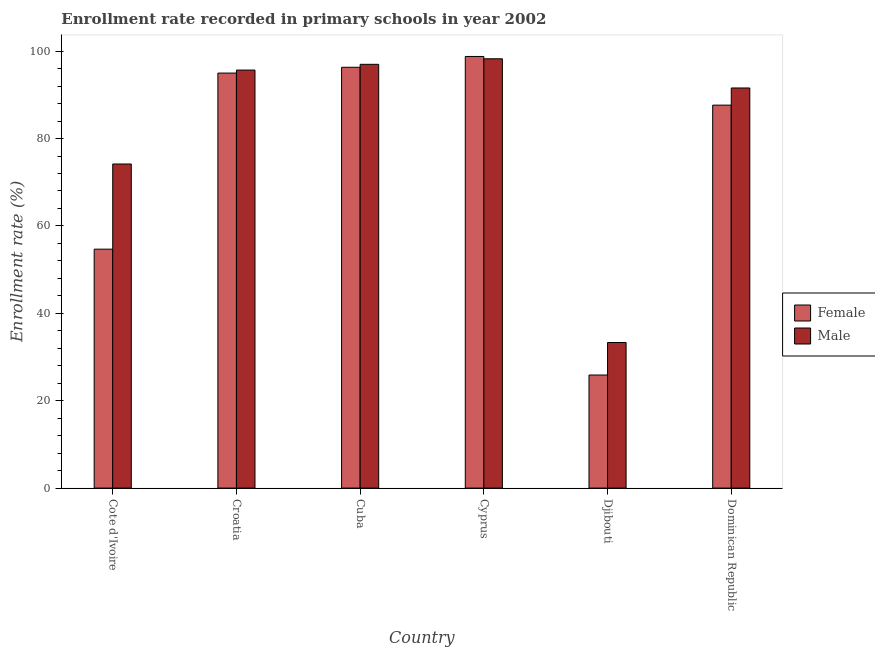How many different coloured bars are there?
Ensure brevity in your answer.  2. Are the number of bars on each tick of the X-axis equal?
Offer a terse response. Yes. How many bars are there on the 2nd tick from the right?
Your answer should be very brief. 2. What is the label of the 3rd group of bars from the left?
Your answer should be compact. Cuba. In how many cases, is the number of bars for a given country not equal to the number of legend labels?
Your answer should be compact. 0. What is the enrollment rate of female students in Cote d'Ivoire?
Give a very brief answer. 54.68. Across all countries, what is the maximum enrollment rate of male students?
Keep it short and to the point. 98.25. Across all countries, what is the minimum enrollment rate of male students?
Provide a succinct answer. 33.32. In which country was the enrollment rate of female students maximum?
Keep it short and to the point. Cyprus. In which country was the enrollment rate of male students minimum?
Give a very brief answer. Djibouti. What is the total enrollment rate of male students in the graph?
Give a very brief answer. 489.96. What is the difference between the enrollment rate of female students in Croatia and that in Dominican Republic?
Provide a short and direct response. 7.34. What is the difference between the enrollment rate of female students in Cote d'Ivoire and the enrollment rate of male students in Dominican Republic?
Ensure brevity in your answer.  -36.89. What is the average enrollment rate of female students per country?
Offer a terse response. 76.38. What is the difference between the enrollment rate of female students and enrollment rate of male students in Croatia?
Give a very brief answer. -0.69. What is the ratio of the enrollment rate of female students in Djibouti to that in Dominican Republic?
Your answer should be compact. 0.3. Is the enrollment rate of female students in Croatia less than that in Cuba?
Ensure brevity in your answer.  Yes. Is the difference between the enrollment rate of male students in Cuba and Dominican Republic greater than the difference between the enrollment rate of female students in Cuba and Dominican Republic?
Your response must be concise. No. What is the difference between the highest and the second highest enrollment rate of male students?
Your answer should be very brief. 1.27. What is the difference between the highest and the lowest enrollment rate of male students?
Make the answer very short. 64.93. Is the sum of the enrollment rate of female students in Cyprus and Dominican Republic greater than the maximum enrollment rate of male students across all countries?
Offer a terse response. Yes. What does the 1st bar from the left in Cyprus represents?
Offer a terse response. Female. What does the 1st bar from the right in Dominican Republic represents?
Your answer should be very brief. Male. How many bars are there?
Your answer should be compact. 12. How many countries are there in the graph?
Give a very brief answer. 6. Does the graph contain any zero values?
Your answer should be very brief. No. Does the graph contain grids?
Your answer should be compact. No. Where does the legend appear in the graph?
Your response must be concise. Center right. How many legend labels are there?
Your answer should be very brief. 2. How are the legend labels stacked?
Ensure brevity in your answer.  Vertical. What is the title of the graph?
Keep it short and to the point. Enrollment rate recorded in primary schools in year 2002. Does "Manufacturing industries and construction" appear as one of the legend labels in the graph?
Give a very brief answer. No. What is the label or title of the X-axis?
Provide a succinct answer. Country. What is the label or title of the Y-axis?
Give a very brief answer. Enrollment rate (%). What is the Enrollment rate (%) in Female in Cote d'Ivoire?
Your response must be concise. 54.68. What is the Enrollment rate (%) of Male in Cote d'Ivoire?
Your response must be concise. 74.17. What is the Enrollment rate (%) of Female in Croatia?
Ensure brevity in your answer.  94.98. What is the Enrollment rate (%) in Male in Croatia?
Provide a short and direct response. 95.66. What is the Enrollment rate (%) of Female in Cuba?
Give a very brief answer. 96.31. What is the Enrollment rate (%) in Male in Cuba?
Give a very brief answer. 96.98. What is the Enrollment rate (%) of Female in Cyprus?
Ensure brevity in your answer.  98.78. What is the Enrollment rate (%) in Male in Cyprus?
Your answer should be compact. 98.25. What is the Enrollment rate (%) in Female in Djibouti?
Provide a short and direct response. 25.88. What is the Enrollment rate (%) in Male in Djibouti?
Your response must be concise. 33.32. What is the Enrollment rate (%) in Female in Dominican Republic?
Keep it short and to the point. 87.64. What is the Enrollment rate (%) of Male in Dominican Republic?
Your answer should be very brief. 91.57. Across all countries, what is the maximum Enrollment rate (%) in Female?
Offer a very short reply. 98.78. Across all countries, what is the maximum Enrollment rate (%) in Male?
Your answer should be very brief. 98.25. Across all countries, what is the minimum Enrollment rate (%) of Female?
Offer a very short reply. 25.88. Across all countries, what is the minimum Enrollment rate (%) of Male?
Your response must be concise. 33.32. What is the total Enrollment rate (%) of Female in the graph?
Ensure brevity in your answer.  458.27. What is the total Enrollment rate (%) in Male in the graph?
Offer a terse response. 489.96. What is the difference between the Enrollment rate (%) in Female in Cote d'Ivoire and that in Croatia?
Offer a very short reply. -40.3. What is the difference between the Enrollment rate (%) of Male in Cote d'Ivoire and that in Croatia?
Offer a terse response. -21.49. What is the difference between the Enrollment rate (%) of Female in Cote d'Ivoire and that in Cuba?
Provide a short and direct response. -41.63. What is the difference between the Enrollment rate (%) in Male in Cote d'Ivoire and that in Cuba?
Keep it short and to the point. -22.81. What is the difference between the Enrollment rate (%) in Female in Cote d'Ivoire and that in Cyprus?
Provide a short and direct response. -44.1. What is the difference between the Enrollment rate (%) in Male in Cote d'Ivoire and that in Cyprus?
Your answer should be compact. -24.08. What is the difference between the Enrollment rate (%) in Female in Cote d'Ivoire and that in Djibouti?
Offer a very short reply. 28.8. What is the difference between the Enrollment rate (%) in Male in Cote d'Ivoire and that in Djibouti?
Your answer should be very brief. 40.85. What is the difference between the Enrollment rate (%) of Female in Cote d'Ivoire and that in Dominican Republic?
Your answer should be compact. -32.96. What is the difference between the Enrollment rate (%) in Male in Cote d'Ivoire and that in Dominican Republic?
Your answer should be very brief. -17.4. What is the difference between the Enrollment rate (%) of Female in Croatia and that in Cuba?
Provide a succinct answer. -1.33. What is the difference between the Enrollment rate (%) of Male in Croatia and that in Cuba?
Your answer should be compact. -1.32. What is the difference between the Enrollment rate (%) of Female in Croatia and that in Cyprus?
Make the answer very short. -3.8. What is the difference between the Enrollment rate (%) in Male in Croatia and that in Cyprus?
Your answer should be compact. -2.58. What is the difference between the Enrollment rate (%) of Female in Croatia and that in Djibouti?
Provide a succinct answer. 69.1. What is the difference between the Enrollment rate (%) of Male in Croatia and that in Djibouti?
Provide a short and direct response. 62.34. What is the difference between the Enrollment rate (%) in Female in Croatia and that in Dominican Republic?
Your answer should be very brief. 7.34. What is the difference between the Enrollment rate (%) of Male in Croatia and that in Dominican Republic?
Make the answer very short. 4.09. What is the difference between the Enrollment rate (%) in Female in Cuba and that in Cyprus?
Offer a terse response. -2.47. What is the difference between the Enrollment rate (%) in Male in Cuba and that in Cyprus?
Your answer should be compact. -1.27. What is the difference between the Enrollment rate (%) of Female in Cuba and that in Djibouti?
Make the answer very short. 70.43. What is the difference between the Enrollment rate (%) of Male in Cuba and that in Djibouti?
Give a very brief answer. 63.66. What is the difference between the Enrollment rate (%) of Female in Cuba and that in Dominican Republic?
Ensure brevity in your answer.  8.67. What is the difference between the Enrollment rate (%) of Male in Cuba and that in Dominican Republic?
Keep it short and to the point. 5.41. What is the difference between the Enrollment rate (%) of Female in Cyprus and that in Djibouti?
Your response must be concise. 72.9. What is the difference between the Enrollment rate (%) in Male in Cyprus and that in Djibouti?
Keep it short and to the point. 64.93. What is the difference between the Enrollment rate (%) of Female in Cyprus and that in Dominican Republic?
Give a very brief answer. 11.14. What is the difference between the Enrollment rate (%) of Male in Cyprus and that in Dominican Republic?
Provide a short and direct response. 6.68. What is the difference between the Enrollment rate (%) in Female in Djibouti and that in Dominican Republic?
Offer a very short reply. -61.76. What is the difference between the Enrollment rate (%) in Male in Djibouti and that in Dominican Republic?
Ensure brevity in your answer.  -58.25. What is the difference between the Enrollment rate (%) of Female in Cote d'Ivoire and the Enrollment rate (%) of Male in Croatia?
Your answer should be very brief. -40.98. What is the difference between the Enrollment rate (%) in Female in Cote d'Ivoire and the Enrollment rate (%) in Male in Cuba?
Provide a short and direct response. -42.3. What is the difference between the Enrollment rate (%) in Female in Cote d'Ivoire and the Enrollment rate (%) in Male in Cyprus?
Ensure brevity in your answer.  -43.57. What is the difference between the Enrollment rate (%) of Female in Cote d'Ivoire and the Enrollment rate (%) of Male in Djibouti?
Offer a terse response. 21.36. What is the difference between the Enrollment rate (%) of Female in Cote d'Ivoire and the Enrollment rate (%) of Male in Dominican Republic?
Keep it short and to the point. -36.89. What is the difference between the Enrollment rate (%) of Female in Croatia and the Enrollment rate (%) of Male in Cuba?
Your answer should be compact. -2. What is the difference between the Enrollment rate (%) in Female in Croatia and the Enrollment rate (%) in Male in Cyprus?
Make the answer very short. -3.27. What is the difference between the Enrollment rate (%) in Female in Croatia and the Enrollment rate (%) in Male in Djibouti?
Keep it short and to the point. 61.66. What is the difference between the Enrollment rate (%) in Female in Croatia and the Enrollment rate (%) in Male in Dominican Republic?
Your answer should be very brief. 3.41. What is the difference between the Enrollment rate (%) in Female in Cuba and the Enrollment rate (%) in Male in Cyprus?
Offer a terse response. -1.94. What is the difference between the Enrollment rate (%) of Female in Cuba and the Enrollment rate (%) of Male in Djibouti?
Ensure brevity in your answer.  62.98. What is the difference between the Enrollment rate (%) of Female in Cuba and the Enrollment rate (%) of Male in Dominican Republic?
Your answer should be compact. 4.74. What is the difference between the Enrollment rate (%) in Female in Cyprus and the Enrollment rate (%) in Male in Djibouti?
Offer a very short reply. 65.46. What is the difference between the Enrollment rate (%) of Female in Cyprus and the Enrollment rate (%) of Male in Dominican Republic?
Your response must be concise. 7.21. What is the difference between the Enrollment rate (%) in Female in Djibouti and the Enrollment rate (%) in Male in Dominican Republic?
Make the answer very short. -65.69. What is the average Enrollment rate (%) in Female per country?
Your response must be concise. 76.38. What is the average Enrollment rate (%) of Male per country?
Provide a succinct answer. 81.66. What is the difference between the Enrollment rate (%) of Female and Enrollment rate (%) of Male in Cote d'Ivoire?
Your answer should be very brief. -19.49. What is the difference between the Enrollment rate (%) of Female and Enrollment rate (%) of Male in Croatia?
Provide a succinct answer. -0.69. What is the difference between the Enrollment rate (%) of Female and Enrollment rate (%) of Male in Cuba?
Provide a succinct answer. -0.68. What is the difference between the Enrollment rate (%) of Female and Enrollment rate (%) of Male in Cyprus?
Provide a succinct answer. 0.53. What is the difference between the Enrollment rate (%) in Female and Enrollment rate (%) in Male in Djibouti?
Offer a terse response. -7.44. What is the difference between the Enrollment rate (%) of Female and Enrollment rate (%) of Male in Dominican Republic?
Offer a terse response. -3.93. What is the ratio of the Enrollment rate (%) of Female in Cote d'Ivoire to that in Croatia?
Your answer should be very brief. 0.58. What is the ratio of the Enrollment rate (%) of Male in Cote d'Ivoire to that in Croatia?
Provide a short and direct response. 0.78. What is the ratio of the Enrollment rate (%) of Female in Cote d'Ivoire to that in Cuba?
Ensure brevity in your answer.  0.57. What is the ratio of the Enrollment rate (%) in Male in Cote d'Ivoire to that in Cuba?
Provide a short and direct response. 0.76. What is the ratio of the Enrollment rate (%) in Female in Cote d'Ivoire to that in Cyprus?
Your answer should be compact. 0.55. What is the ratio of the Enrollment rate (%) of Male in Cote d'Ivoire to that in Cyprus?
Make the answer very short. 0.75. What is the ratio of the Enrollment rate (%) of Female in Cote d'Ivoire to that in Djibouti?
Provide a succinct answer. 2.11. What is the ratio of the Enrollment rate (%) in Male in Cote d'Ivoire to that in Djibouti?
Your response must be concise. 2.23. What is the ratio of the Enrollment rate (%) of Female in Cote d'Ivoire to that in Dominican Republic?
Your response must be concise. 0.62. What is the ratio of the Enrollment rate (%) in Male in Cote d'Ivoire to that in Dominican Republic?
Provide a succinct answer. 0.81. What is the ratio of the Enrollment rate (%) in Female in Croatia to that in Cuba?
Offer a terse response. 0.99. What is the ratio of the Enrollment rate (%) of Male in Croatia to that in Cuba?
Offer a very short reply. 0.99. What is the ratio of the Enrollment rate (%) in Female in Croatia to that in Cyprus?
Your answer should be very brief. 0.96. What is the ratio of the Enrollment rate (%) in Male in Croatia to that in Cyprus?
Ensure brevity in your answer.  0.97. What is the ratio of the Enrollment rate (%) in Female in Croatia to that in Djibouti?
Offer a terse response. 3.67. What is the ratio of the Enrollment rate (%) of Male in Croatia to that in Djibouti?
Offer a very short reply. 2.87. What is the ratio of the Enrollment rate (%) of Female in Croatia to that in Dominican Republic?
Provide a short and direct response. 1.08. What is the ratio of the Enrollment rate (%) in Male in Croatia to that in Dominican Republic?
Your response must be concise. 1.04. What is the ratio of the Enrollment rate (%) of Male in Cuba to that in Cyprus?
Provide a succinct answer. 0.99. What is the ratio of the Enrollment rate (%) in Female in Cuba to that in Djibouti?
Offer a terse response. 3.72. What is the ratio of the Enrollment rate (%) of Male in Cuba to that in Djibouti?
Ensure brevity in your answer.  2.91. What is the ratio of the Enrollment rate (%) in Female in Cuba to that in Dominican Republic?
Give a very brief answer. 1.1. What is the ratio of the Enrollment rate (%) in Male in Cuba to that in Dominican Republic?
Ensure brevity in your answer.  1.06. What is the ratio of the Enrollment rate (%) of Female in Cyprus to that in Djibouti?
Offer a terse response. 3.82. What is the ratio of the Enrollment rate (%) in Male in Cyprus to that in Djibouti?
Your answer should be very brief. 2.95. What is the ratio of the Enrollment rate (%) in Female in Cyprus to that in Dominican Republic?
Give a very brief answer. 1.13. What is the ratio of the Enrollment rate (%) of Male in Cyprus to that in Dominican Republic?
Offer a terse response. 1.07. What is the ratio of the Enrollment rate (%) in Female in Djibouti to that in Dominican Republic?
Make the answer very short. 0.3. What is the ratio of the Enrollment rate (%) of Male in Djibouti to that in Dominican Republic?
Keep it short and to the point. 0.36. What is the difference between the highest and the second highest Enrollment rate (%) of Female?
Provide a short and direct response. 2.47. What is the difference between the highest and the second highest Enrollment rate (%) of Male?
Keep it short and to the point. 1.27. What is the difference between the highest and the lowest Enrollment rate (%) in Female?
Your answer should be compact. 72.9. What is the difference between the highest and the lowest Enrollment rate (%) in Male?
Provide a short and direct response. 64.93. 